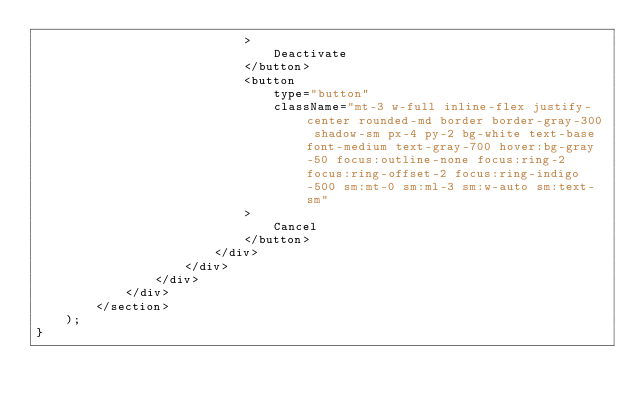<code> <loc_0><loc_0><loc_500><loc_500><_JavaScript_>                            >
                                Deactivate
                            </button>
                            <button
                                type="button"
                                className="mt-3 w-full inline-flex justify-center rounded-md border border-gray-300 shadow-sm px-4 py-2 bg-white text-base font-medium text-gray-700 hover:bg-gray-50 focus:outline-none focus:ring-2 focus:ring-offset-2 focus:ring-indigo-500 sm:mt-0 sm:ml-3 sm:w-auto sm:text-sm"
                            >
                                Cancel
                            </button>
                        </div>
                    </div>
                </div>
            </div>
        </section>
    );
}
</code> 